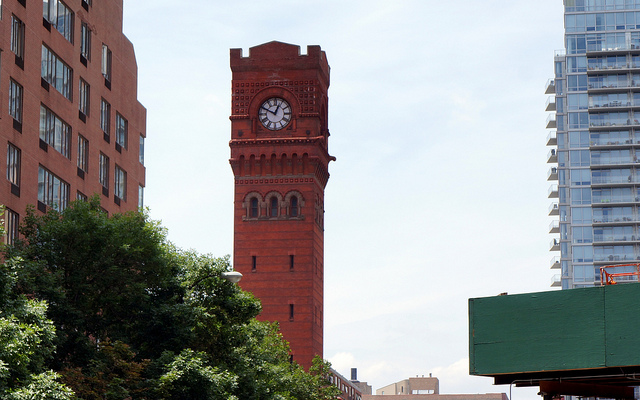How many arched windows under the clock? There are three beautifully arched windows situated directly below the clock on the tower. 